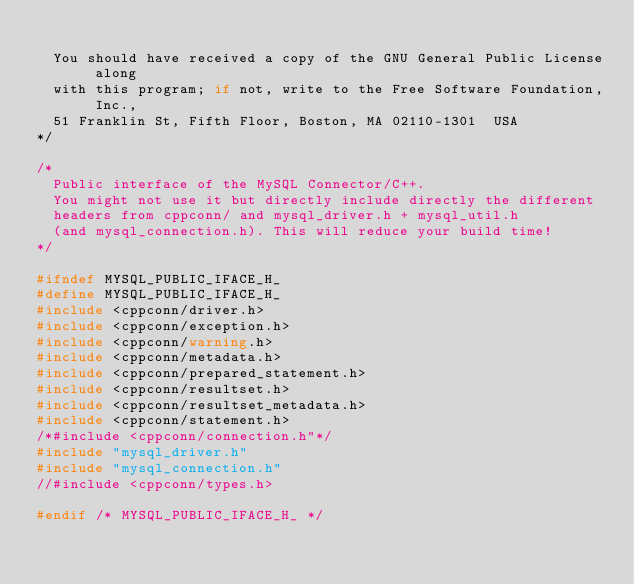Convert code to text. <code><loc_0><loc_0><loc_500><loc_500><_C_>
  You should have received a copy of the GNU General Public License along
  with this program; if not, write to the Free Software Foundation, Inc.,
  51 Franklin St, Fifth Floor, Boston, MA 02110-1301  USA
*/

/*
  Public interface of the MySQL Connector/C++.
  You might not use it but directly include directly the different
  headers from cppconn/ and mysql_driver.h + mysql_util.h
  (and mysql_connection.h). This will reduce your build time!
*/

#ifndef MYSQL_PUBLIC_IFACE_H_
#define MYSQL_PUBLIC_IFACE_H_
#include <cppconn/driver.h>
#include <cppconn/exception.h>
#include <cppconn/warning.h>
#include <cppconn/metadata.h>
#include <cppconn/prepared_statement.h>
#include <cppconn/resultset.h>
#include <cppconn/resultset_metadata.h>
#include <cppconn/statement.h>
/*#include <cppconn/connection.h"*/
#include "mysql_driver.h"
#include "mysql_connection.h"
//#include <cppconn/types.h>

#endif /* MYSQL_PUBLIC_IFACE_H_ */
</code> 